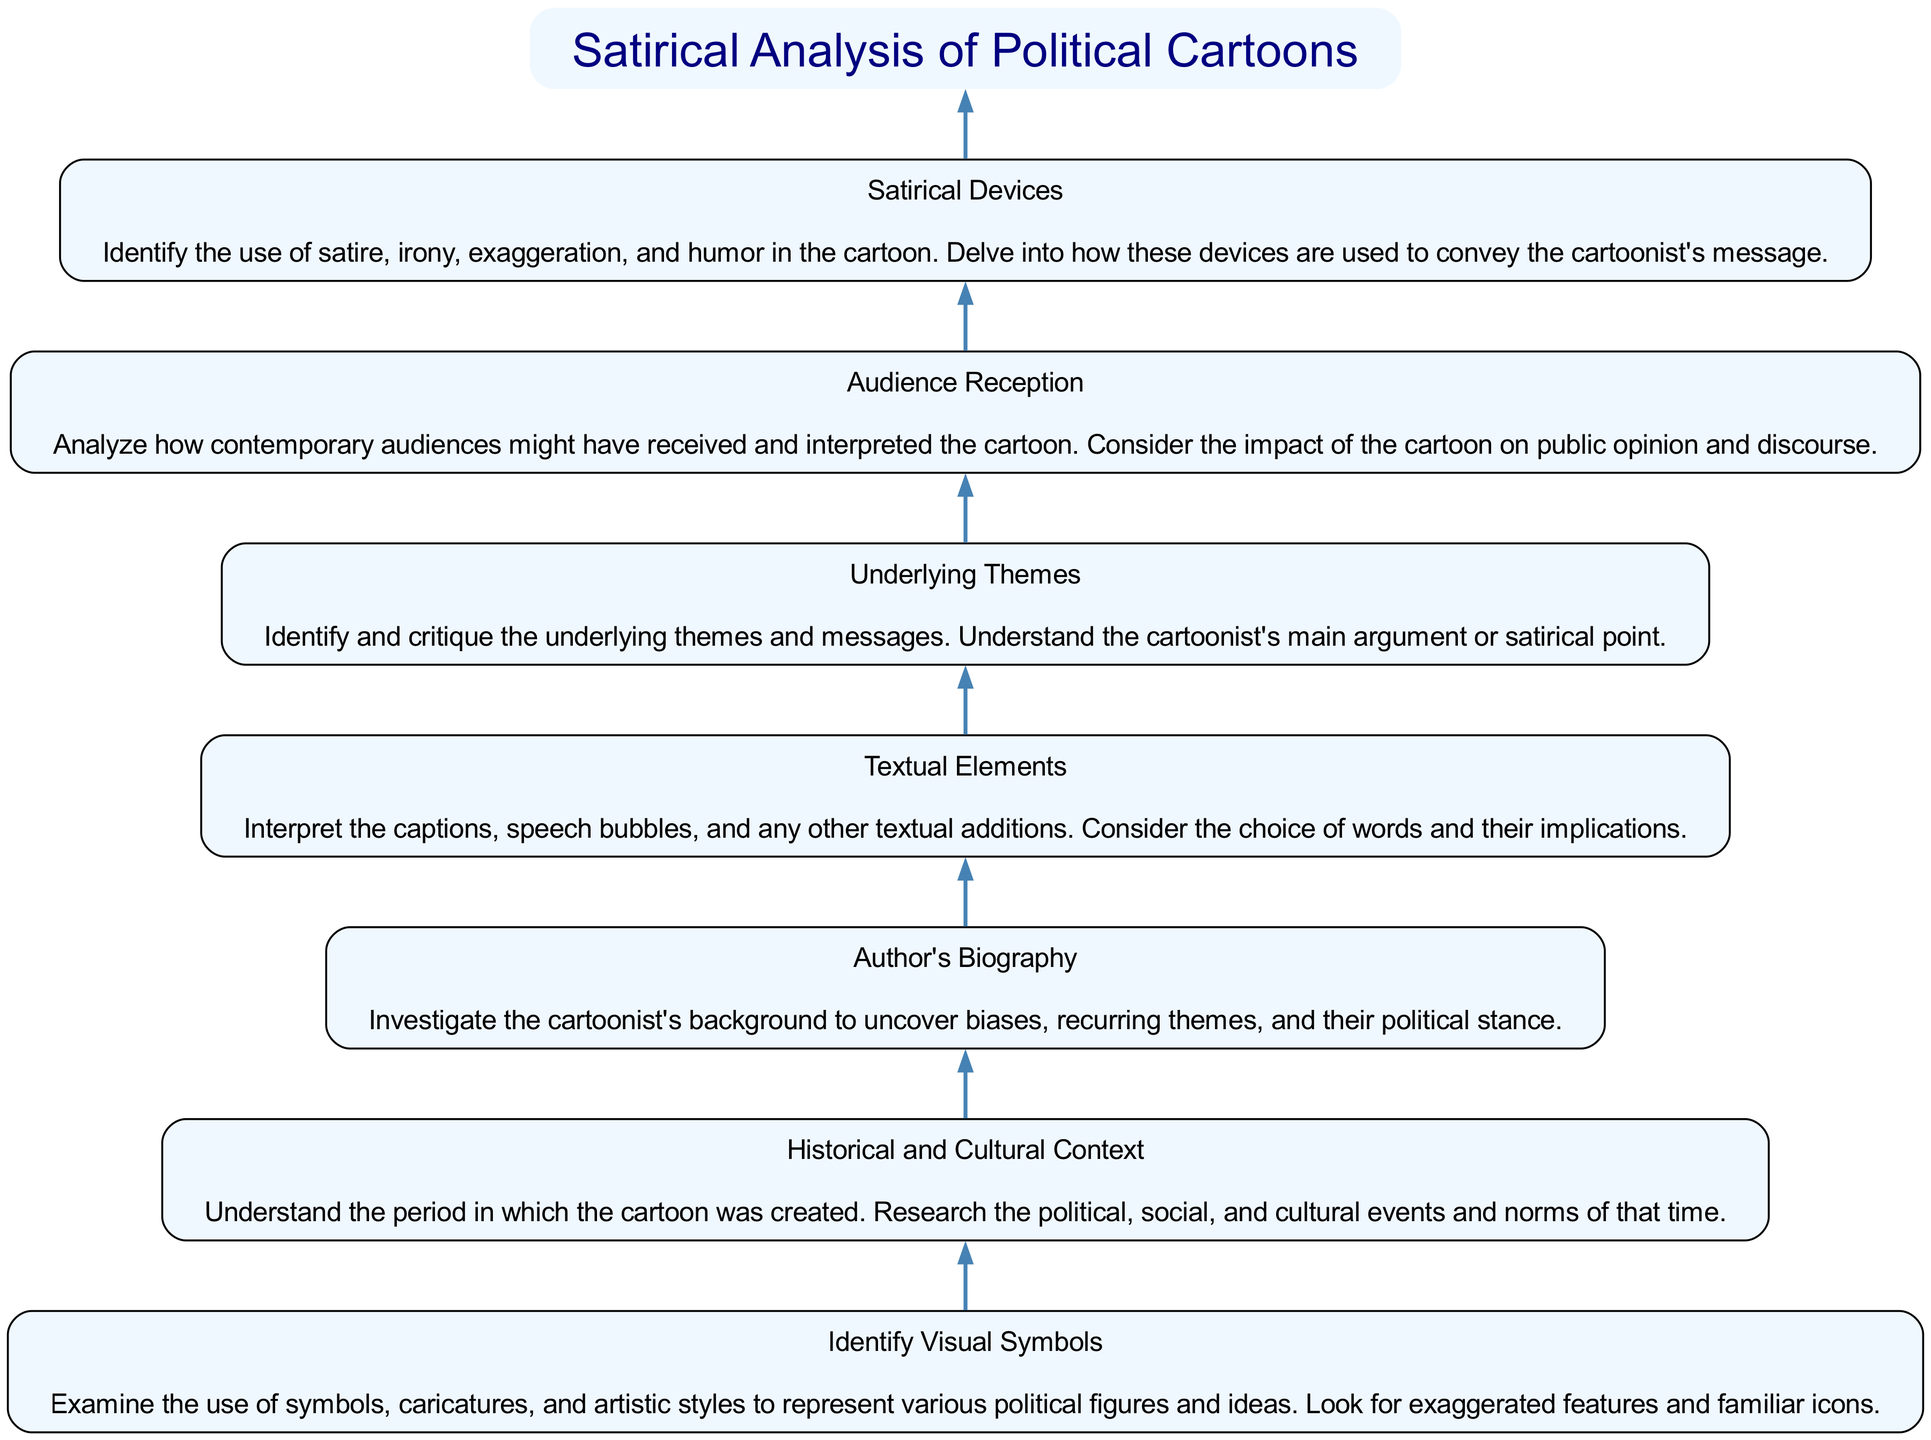What is the topmost node in the diagram? The topmost node is the title of the flow chart, which is "Satirical Analysis of Political Cartoons." Since flow charts often have a hierarchy, the topmost node is the most important or overarching concept that governs the flow of information below it.
Answer: Satirical Analysis of Political Cartoons How many steps are involved in the analysis? There are seven steps outlined in the analysis of satirical cartoons: Identify Visual Symbols, Historical and Cultural Context, Author's Biography, Textual Elements, Underlying Themes, Audience Reception, and Satirical Devices. By counting each node that represents an analysis step, we can determine the total number of steps.
Answer: Seven What is the relationship between "Identify Visual Symbols" and "Underlying Themes"? "Identify Visual Symbols" is the first step and leads to subsequent analysis nodes, with "Underlying Themes" being the fifth step in the sequence. Each step in a flow chart typically leads to or builds on the previous one, showing a progression from simple identification to more complex interpretation.
Answer: Sequential relationship Which step comes immediately after "Historical and Cultural Context"? The step that comes immediately after "Historical and Cultural Context" is "Author's Biography." This follows logically as understanding the biographies of cartoonists can provide context in evaluating their work and the cultural environment of their creations.
Answer: Author's Biography What is the main focus of "Satirical Devices"? The main focus is on identifying the use of satire, irony, exaggeration, and humor in the cartoon to uncover how these devices convey the cartoonist's message. It includes understanding specific techniques and how they shape the viewer's perception of political commentary.
Answer: Satire, irony, exaggeration, and humor Which step evaluates how audiences received the cartoons? The step that evaluates audience reception is "Audience Reception." This step critically analyzes how the contemporary audience perceived the cartoon and its impact on public opinion, thus completing the cycle of understanding cartoons from creation to consumption.
Answer: Audience Reception What is the final insight provided by the diagram regarding political cartoons? The final insight is usually derived from the last step, which highlights the critical analysis of "Satirical Devices." Understanding how satire operates within the cartoons ties together the insights from all previous steps, culminating the analysis.
Answer: Critical analysis of satire How does "Textual Elements" contribute to understanding a cartoon? "Textual Elements" contributes by interpreting the captions and text to uncover their implications, which can enrich the viewer's understanding of the cartoon's message beyond the visual imagery alone. This step highlights the importance of textual context in satirical analysis.
Answer: Interpreting captions and implications 